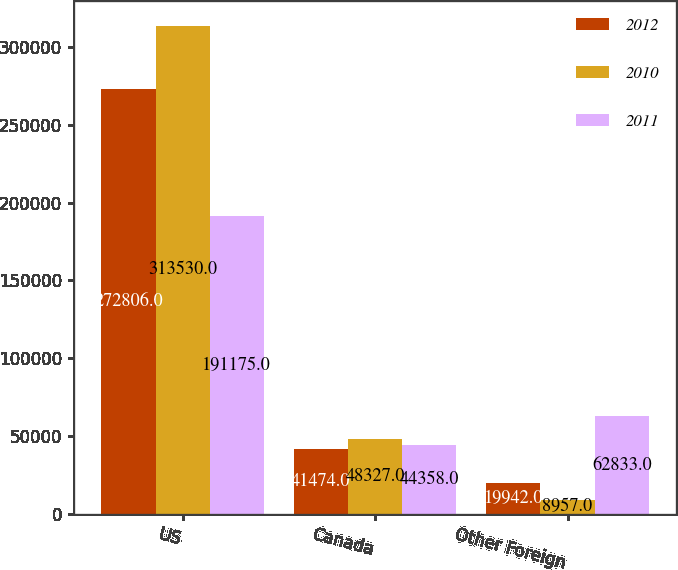<chart> <loc_0><loc_0><loc_500><loc_500><stacked_bar_chart><ecel><fcel>US<fcel>Canada<fcel>Other Foreign<nl><fcel>2012<fcel>272806<fcel>41474<fcel>19942<nl><fcel>2010<fcel>313530<fcel>48327<fcel>8957<nl><fcel>2011<fcel>191175<fcel>44358<fcel>62833<nl></chart> 